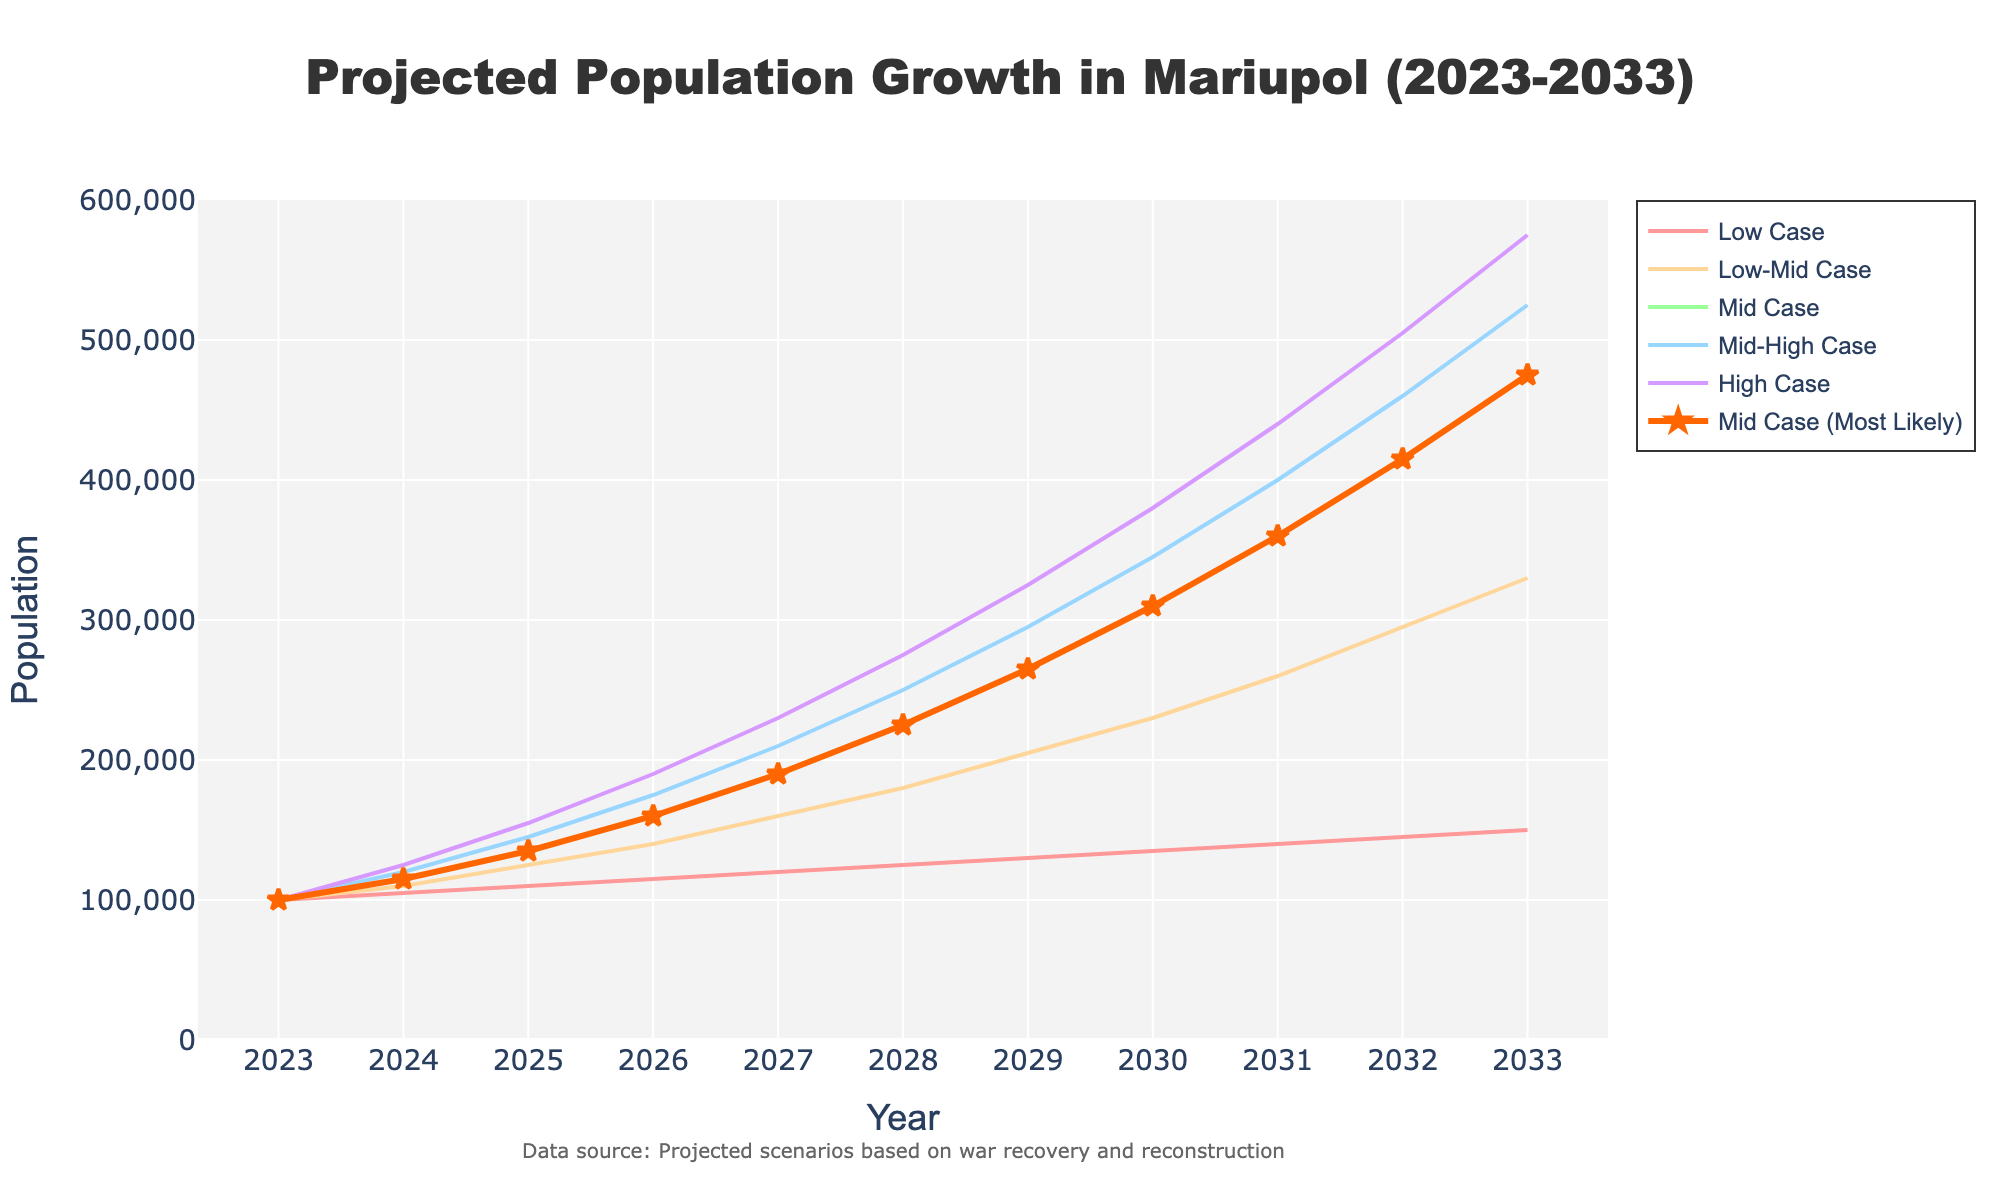What is the projected population of Mariupol in the Mid Case for the year 2025? The figure shows different population projections. For the year 2025, the Mid Case projection can be directly read from the Mid Case line.
Answer: 135,000 What is the difference between the High Case scenario and the Low Case scenario in 2030? The figure gives the projected populations for both High Case and Low Case in 2030. Subtract the Low Case value (135,000) from the High Case value (380,000).
Answer: 245,000 How does the population trend in the Low-Mid Case change from 2026 to 2028? Check the Low-Mid Case line from 2026 to 2028. In 2026, the population is 140,000 and in 2028 it is 180,000. The population increases from 140,000 to 180,000.
Answer: Increases by 40,000 Which scenario shows the highest population projection for the year 2033? Look at the population values for all scenarios in 2033. The High Case scenario has the highest value.
Answer: High Case How many years does it take for the High Case scenario to surpass the population of 300,000? Locate the High Case line and check when it first surpasses 300,000. In 2030, the High Case reaches 380,000. Count the years from 2023 to 2030.
Answer: 7 years What is the ratio of populations between the Mid-High Case and the Mid Case in 2029? Find the populations for the Mid-High Case and Mid Case in 2029. The Mid-High Case is 295,000 and the Mid Case is 265,000. Divide 295,000 by 265,000.
Answer: 1.11 Between which years does the Mid Case show the largest population increase? Calculate population increases between consecutive years for the Mid Case. The largest increase occurs between 2027 (190,000) and 2028 (225,000), which is 35,000.
Answer: 2027 to 2028 By what percentage does the Low Case population grow from 2023 to 2033? Calculate the percentage increase from 100,000 in 2023 to 150,000 in 2033. Use the formula \(( \frac{150,000 - 100,000}{100,000} ) \times 100\%\).
Answer: 50% Which scenario shows the fastest growth rate from 2023 to 2033? Compare the total increase for each scenario over this period. The High Case goes from 100,000 to 575,000 (an increase of 475,000), which is the highest.
Answer: High Case What is the expected population in the Low-Mid Case scenario in the midpoint year between 2025 and 2029? First, find the midpoint year, which is 2027. Then, check the projected population for the Low-Mid Case in 2027, which is 160,000.
Answer: 160,000 